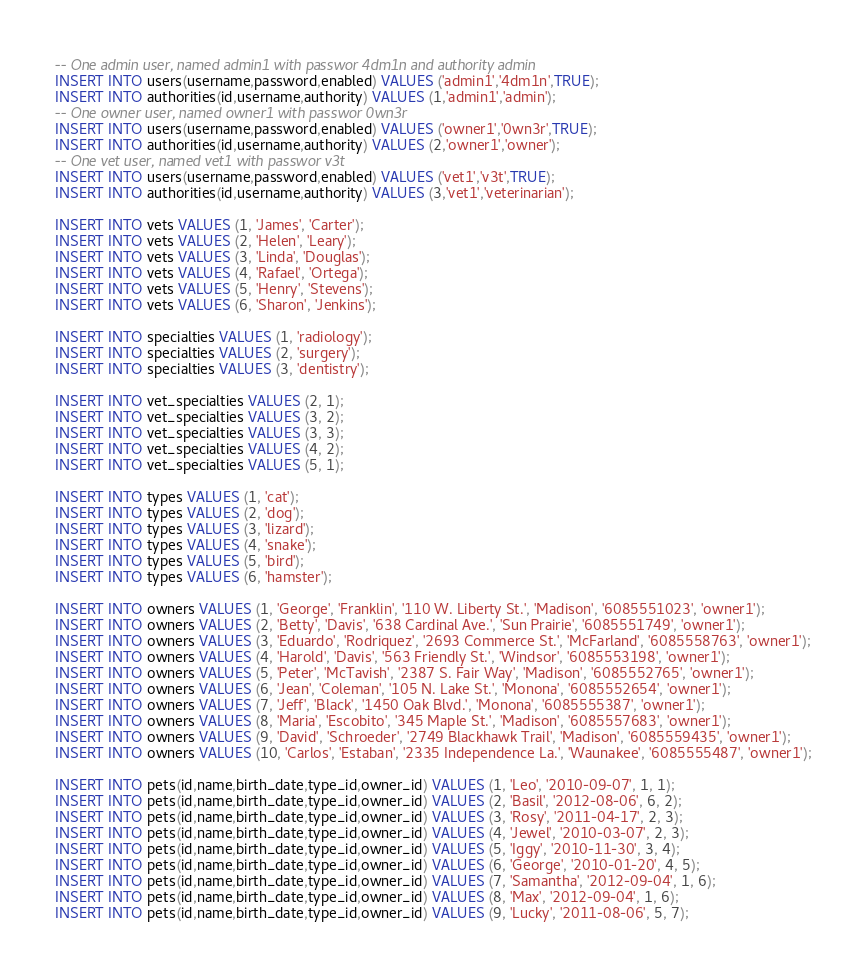<code> <loc_0><loc_0><loc_500><loc_500><_SQL_>-- One admin user, named admin1 with passwor 4dm1n and authority admin
INSERT INTO users(username,password,enabled) VALUES ('admin1','4dm1n',TRUE);
INSERT INTO authorities(id,username,authority) VALUES (1,'admin1','admin');
-- One owner user, named owner1 with passwor 0wn3r
INSERT INTO users(username,password,enabled) VALUES ('owner1','0wn3r',TRUE);
INSERT INTO authorities(id,username,authority) VALUES (2,'owner1','owner');
-- One vet user, named vet1 with passwor v3t
INSERT INTO users(username,password,enabled) VALUES ('vet1','v3t',TRUE);
INSERT INTO authorities(id,username,authority) VALUES (3,'vet1','veterinarian');

INSERT INTO vets VALUES (1, 'James', 'Carter');
INSERT INTO vets VALUES (2, 'Helen', 'Leary');
INSERT INTO vets VALUES (3, 'Linda', 'Douglas');
INSERT INTO vets VALUES (4, 'Rafael', 'Ortega');
INSERT INTO vets VALUES (5, 'Henry', 'Stevens');
INSERT INTO vets VALUES (6, 'Sharon', 'Jenkins');

INSERT INTO specialties VALUES (1, 'radiology');
INSERT INTO specialties VALUES (2, 'surgery');
INSERT INTO specialties VALUES (3, 'dentistry');

INSERT INTO vet_specialties VALUES (2, 1);
INSERT INTO vet_specialties VALUES (3, 2);
INSERT INTO vet_specialties VALUES (3, 3);
INSERT INTO vet_specialties VALUES (4, 2);
INSERT INTO vet_specialties VALUES (5, 1);

INSERT INTO types VALUES (1, 'cat');
INSERT INTO types VALUES (2, 'dog');
INSERT INTO types VALUES (3, 'lizard');
INSERT INTO types VALUES (4, 'snake');
INSERT INTO types VALUES (5, 'bird');
INSERT INTO types VALUES (6, 'hamster');

INSERT INTO owners VALUES (1, 'George', 'Franklin', '110 W. Liberty St.', 'Madison', '6085551023', 'owner1');
INSERT INTO owners VALUES (2, 'Betty', 'Davis', '638 Cardinal Ave.', 'Sun Prairie', '6085551749', 'owner1');
INSERT INTO owners VALUES (3, 'Eduardo', 'Rodriquez', '2693 Commerce St.', 'McFarland', '6085558763', 'owner1');
INSERT INTO owners VALUES (4, 'Harold', 'Davis', '563 Friendly St.', 'Windsor', '6085553198', 'owner1');
INSERT INTO owners VALUES (5, 'Peter', 'McTavish', '2387 S. Fair Way', 'Madison', '6085552765', 'owner1');
INSERT INTO owners VALUES (6, 'Jean', 'Coleman', '105 N. Lake St.', 'Monona', '6085552654', 'owner1');
INSERT INTO owners VALUES (7, 'Jeff', 'Black', '1450 Oak Blvd.', 'Monona', '6085555387', 'owner1');
INSERT INTO owners VALUES (8, 'Maria', 'Escobito', '345 Maple St.', 'Madison', '6085557683', 'owner1');
INSERT INTO owners VALUES (9, 'David', 'Schroeder', '2749 Blackhawk Trail', 'Madison', '6085559435', 'owner1');
INSERT INTO owners VALUES (10, 'Carlos', 'Estaban', '2335 Independence La.', 'Waunakee', '6085555487', 'owner1');

INSERT INTO pets(id,name,birth_date,type_id,owner_id) VALUES (1, 'Leo', '2010-09-07', 1, 1);
INSERT INTO pets(id,name,birth_date,type_id,owner_id) VALUES (2, 'Basil', '2012-08-06', 6, 2);
INSERT INTO pets(id,name,birth_date,type_id,owner_id) VALUES (3, 'Rosy', '2011-04-17', 2, 3);
INSERT INTO pets(id,name,birth_date,type_id,owner_id) VALUES (4, 'Jewel', '2010-03-07', 2, 3);
INSERT INTO pets(id,name,birth_date,type_id,owner_id) VALUES (5, 'Iggy', '2010-11-30', 3, 4);
INSERT INTO pets(id,name,birth_date,type_id,owner_id) VALUES (6, 'George', '2010-01-20', 4, 5);
INSERT INTO pets(id,name,birth_date,type_id,owner_id) VALUES (7, 'Samantha', '2012-09-04', 1, 6);
INSERT INTO pets(id,name,birth_date,type_id,owner_id) VALUES (8, 'Max', '2012-09-04', 1, 6);
INSERT INTO pets(id,name,birth_date,type_id,owner_id) VALUES (9, 'Lucky', '2011-08-06', 5, 7);</code> 